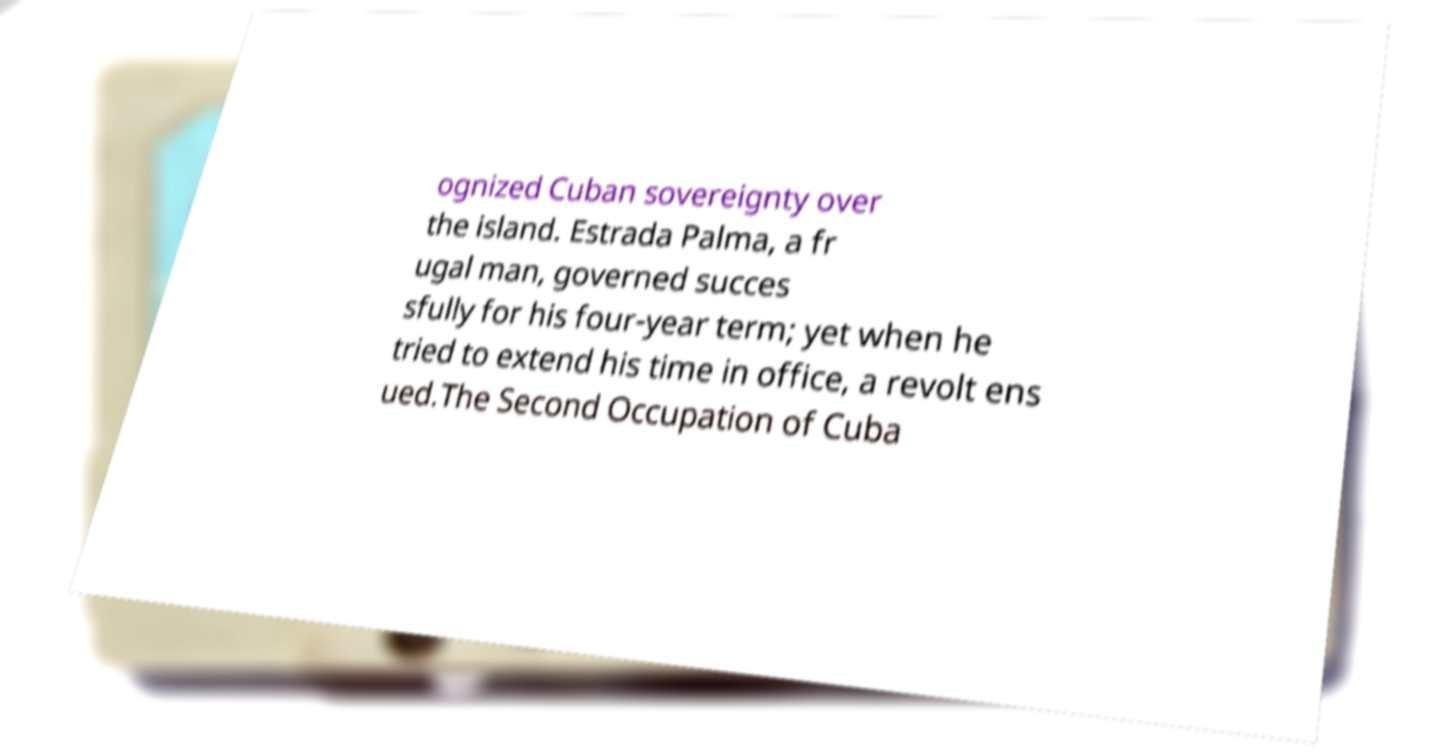Please identify and transcribe the text found in this image. ognized Cuban sovereignty over the island. Estrada Palma, a fr ugal man, governed succes sfully for his four-year term; yet when he tried to extend his time in office, a revolt ens ued.The Second Occupation of Cuba 